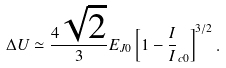Convert formula to latex. <formula><loc_0><loc_0><loc_500><loc_500>\Delta U \simeq \frac { 4 \sqrt { 2 } } { 3 } E _ { J 0 } \left [ 1 - \frac { I } { I } _ { c 0 } \right ] ^ { 3 / 2 } .</formula> 